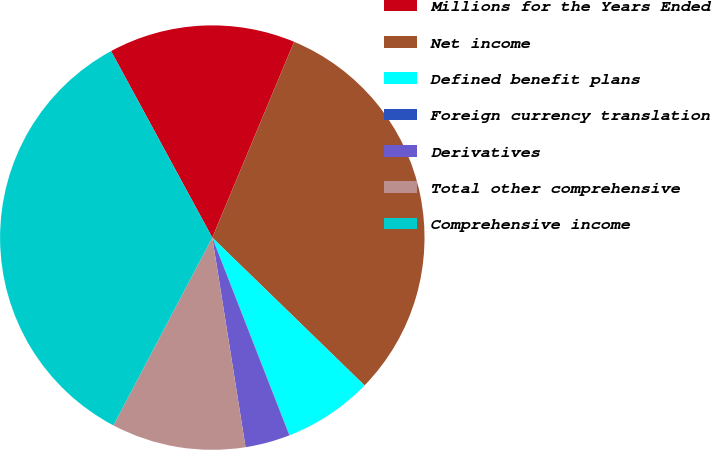Convert chart to OTSL. <chart><loc_0><loc_0><loc_500><loc_500><pie_chart><fcel>Millions for the Years Ended<fcel>Net income<fcel>Defined benefit plans<fcel>Foreign currency translation<fcel>Derivatives<fcel>Total other comprehensive<fcel>Comprehensive income<nl><fcel>14.21%<fcel>30.97%<fcel>6.81%<fcel>0.01%<fcel>3.41%<fcel>10.22%<fcel>34.37%<nl></chart> 